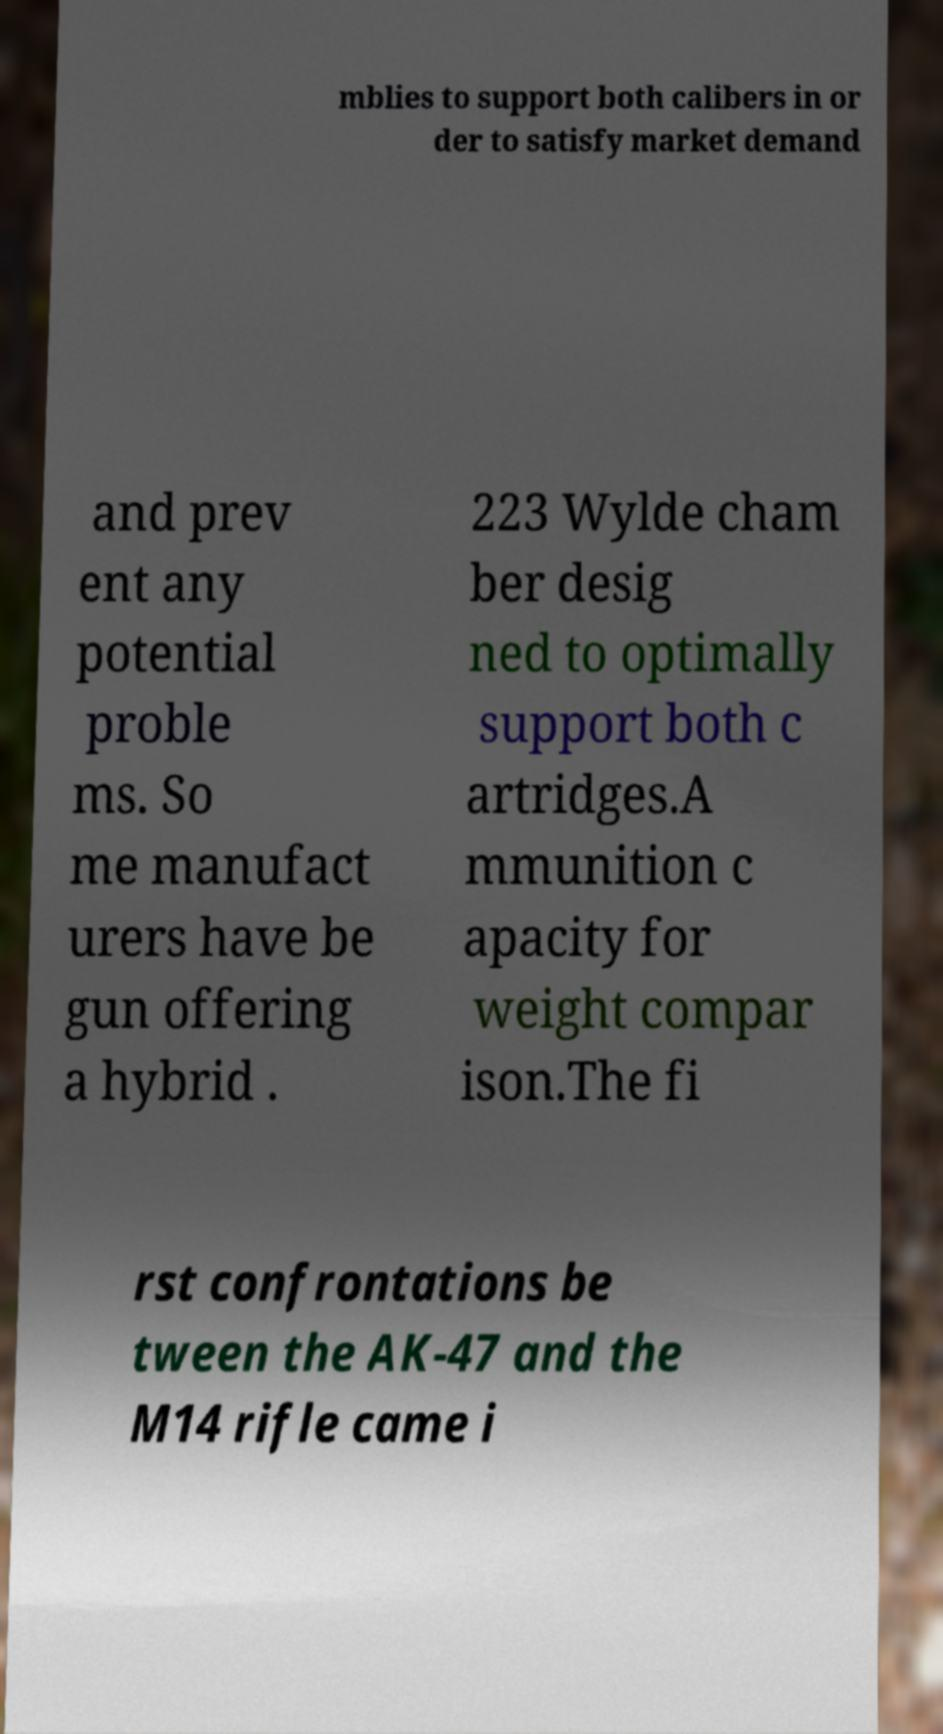For documentation purposes, I need the text within this image transcribed. Could you provide that? mblies to support both calibers in or der to satisfy market demand and prev ent any potential proble ms. So me manufact urers have be gun offering a hybrid . 223 Wylde cham ber desig ned to optimally support both c artridges.A mmunition c apacity for weight compar ison.The fi rst confrontations be tween the AK-47 and the M14 rifle came i 